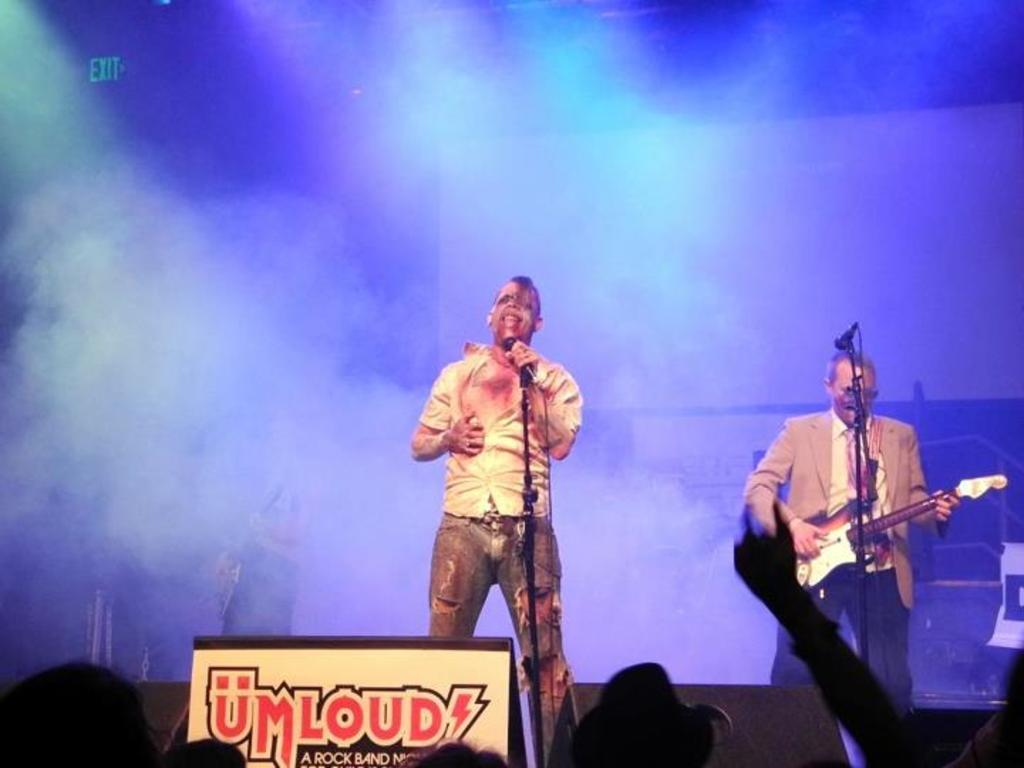How many people are performing in the image? There are two men in the image. What are the two men doing on stage? One man is playing a guitar, and the other man is singing into a microphone. What can be seen in the background of the image? The background of the image includes people. How does the image appear in terms of visibility? The image appears smoky. What type of blood is visible on the guitar in the image? There is no blood visible on the guitar or any other part of the image. 